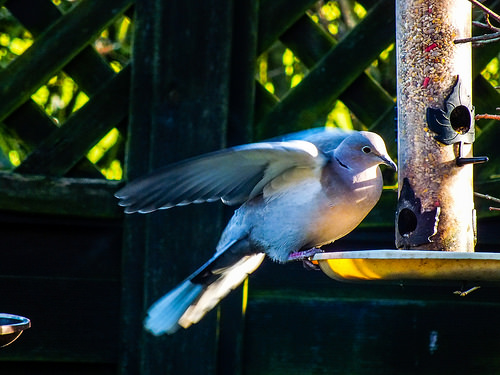<image>
Is there a bird on the feeder? Yes. Looking at the image, I can see the bird is positioned on top of the feeder, with the feeder providing support. Where is the bird in relation to the fence? Is it in the fence? No. The bird is not contained within the fence. These objects have a different spatial relationship. 